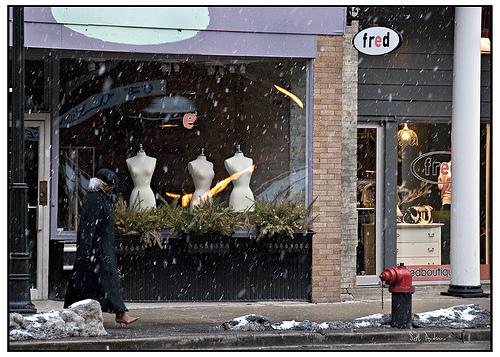Do the mannequins have heads?
Concise answer only. No. How many mannequins do you see?
Write a very short answer. 3. Is one of the shops called Fred?
Concise answer only. Yes. 